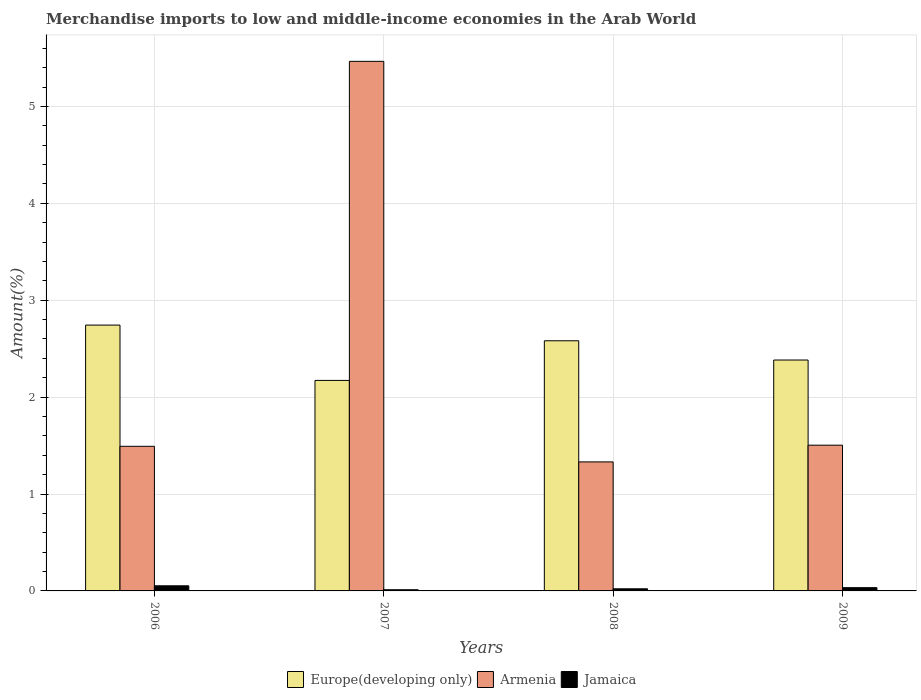How many groups of bars are there?
Keep it short and to the point. 4. Are the number of bars on each tick of the X-axis equal?
Your response must be concise. Yes. In how many cases, is the number of bars for a given year not equal to the number of legend labels?
Make the answer very short. 0. What is the percentage of amount earned from merchandise imports in Armenia in 2007?
Offer a very short reply. 5.47. Across all years, what is the maximum percentage of amount earned from merchandise imports in Armenia?
Make the answer very short. 5.47. Across all years, what is the minimum percentage of amount earned from merchandise imports in Jamaica?
Your answer should be very brief. 0.01. In which year was the percentage of amount earned from merchandise imports in Europe(developing only) maximum?
Your answer should be compact. 2006. In which year was the percentage of amount earned from merchandise imports in Europe(developing only) minimum?
Your answer should be compact. 2007. What is the total percentage of amount earned from merchandise imports in Jamaica in the graph?
Offer a very short reply. 0.12. What is the difference between the percentage of amount earned from merchandise imports in Jamaica in 2007 and that in 2008?
Ensure brevity in your answer.  -0.01. What is the difference between the percentage of amount earned from merchandise imports in Europe(developing only) in 2007 and the percentage of amount earned from merchandise imports in Armenia in 2006?
Make the answer very short. 0.68. What is the average percentage of amount earned from merchandise imports in Europe(developing only) per year?
Provide a succinct answer. 2.47. In the year 2009, what is the difference between the percentage of amount earned from merchandise imports in Europe(developing only) and percentage of amount earned from merchandise imports in Armenia?
Ensure brevity in your answer.  0.88. In how many years, is the percentage of amount earned from merchandise imports in Armenia greater than 2.2 %?
Offer a very short reply. 1. What is the ratio of the percentage of amount earned from merchandise imports in Europe(developing only) in 2007 to that in 2009?
Offer a terse response. 0.91. Is the difference between the percentage of amount earned from merchandise imports in Europe(developing only) in 2007 and 2009 greater than the difference between the percentage of amount earned from merchandise imports in Armenia in 2007 and 2009?
Provide a succinct answer. No. What is the difference between the highest and the second highest percentage of amount earned from merchandise imports in Jamaica?
Give a very brief answer. 0.02. What is the difference between the highest and the lowest percentage of amount earned from merchandise imports in Europe(developing only)?
Your response must be concise. 0.57. In how many years, is the percentage of amount earned from merchandise imports in Jamaica greater than the average percentage of amount earned from merchandise imports in Jamaica taken over all years?
Your response must be concise. 2. Is the sum of the percentage of amount earned from merchandise imports in Europe(developing only) in 2007 and 2008 greater than the maximum percentage of amount earned from merchandise imports in Jamaica across all years?
Ensure brevity in your answer.  Yes. What does the 1st bar from the left in 2008 represents?
Your answer should be very brief. Europe(developing only). What does the 3rd bar from the right in 2009 represents?
Your answer should be compact. Europe(developing only). Is it the case that in every year, the sum of the percentage of amount earned from merchandise imports in Armenia and percentage of amount earned from merchandise imports in Europe(developing only) is greater than the percentage of amount earned from merchandise imports in Jamaica?
Keep it short and to the point. Yes. Are all the bars in the graph horizontal?
Your answer should be compact. No. Does the graph contain any zero values?
Offer a terse response. No. Where does the legend appear in the graph?
Your answer should be very brief. Bottom center. How many legend labels are there?
Your answer should be very brief. 3. How are the legend labels stacked?
Give a very brief answer. Horizontal. What is the title of the graph?
Provide a succinct answer. Merchandise imports to low and middle-income economies in the Arab World. Does "Turkmenistan" appear as one of the legend labels in the graph?
Ensure brevity in your answer.  No. What is the label or title of the X-axis?
Make the answer very short. Years. What is the label or title of the Y-axis?
Give a very brief answer. Amount(%). What is the Amount(%) of Europe(developing only) in 2006?
Ensure brevity in your answer.  2.74. What is the Amount(%) in Armenia in 2006?
Provide a short and direct response. 1.49. What is the Amount(%) of Jamaica in 2006?
Your response must be concise. 0.05. What is the Amount(%) in Europe(developing only) in 2007?
Your answer should be compact. 2.17. What is the Amount(%) in Armenia in 2007?
Offer a terse response. 5.47. What is the Amount(%) in Jamaica in 2007?
Your answer should be very brief. 0.01. What is the Amount(%) in Europe(developing only) in 2008?
Keep it short and to the point. 2.58. What is the Amount(%) in Armenia in 2008?
Provide a succinct answer. 1.33. What is the Amount(%) of Jamaica in 2008?
Provide a short and direct response. 0.02. What is the Amount(%) in Europe(developing only) in 2009?
Provide a short and direct response. 2.38. What is the Amount(%) in Armenia in 2009?
Offer a very short reply. 1.5. What is the Amount(%) of Jamaica in 2009?
Offer a terse response. 0.03. Across all years, what is the maximum Amount(%) of Europe(developing only)?
Provide a short and direct response. 2.74. Across all years, what is the maximum Amount(%) of Armenia?
Ensure brevity in your answer.  5.47. Across all years, what is the maximum Amount(%) in Jamaica?
Give a very brief answer. 0.05. Across all years, what is the minimum Amount(%) in Europe(developing only)?
Your answer should be very brief. 2.17. Across all years, what is the minimum Amount(%) of Armenia?
Offer a very short reply. 1.33. Across all years, what is the minimum Amount(%) of Jamaica?
Ensure brevity in your answer.  0.01. What is the total Amount(%) in Europe(developing only) in the graph?
Your response must be concise. 9.88. What is the total Amount(%) of Armenia in the graph?
Make the answer very short. 9.79. What is the total Amount(%) of Jamaica in the graph?
Keep it short and to the point. 0.12. What is the difference between the Amount(%) of Europe(developing only) in 2006 and that in 2007?
Your response must be concise. 0.57. What is the difference between the Amount(%) of Armenia in 2006 and that in 2007?
Make the answer very short. -3.97. What is the difference between the Amount(%) of Jamaica in 2006 and that in 2007?
Provide a succinct answer. 0.04. What is the difference between the Amount(%) in Europe(developing only) in 2006 and that in 2008?
Keep it short and to the point. 0.16. What is the difference between the Amount(%) of Armenia in 2006 and that in 2008?
Give a very brief answer. 0.16. What is the difference between the Amount(%) in Jamaica in 2006 and that in 2008?
Give a very brief answer. 0.03. What is the difference between the Amount(%) in Europe(developing only) in 2006 and that in 2009?
Ensure brevity in your answer.  0.36. What is the difference between the Amount(%) in Armenia in 2006 and that in 2009?
Your response must be concise. -0.01. What is the difference between the Amount(%) of Jamaica in 2006 and that in 2009?
Offer a terse response. 0.02. What is the difference between the Amount(%) in Europe(developing only) in 2007 and that in 2008?
Your answer should be compact. -0.41. What is the difference between the Amount(%) of Armenia in 2007 and that in 2008?
Provide a succinct answer. 4.13. What is the difference between the Amount(%) in Jamaica in 2007 and that in 2008?
Your response must be concise. -0.01. What is the difference between the Amount(%) in Europe(developing only) in 2007 and that in 2009?
Provide a short and direct response. -0.21. What is the difference between the Amount(%) in Armenia in 2007 and that in 2009?
Offer a very short reply. 3.96. What is the difference between the Amount(%) of Jamaica in 2007 and that in 2009?
Offer a terse response. -0.02. What is the difference between the Amount(%) of Europe(developing only) in 2008 and that in 2009?
Provide a short and direct response. 0.2. What is the difference between the Amount(%) in Armenia in 2008 and that in 2009?
Provide a short and direct response. -0.17. What is the difference between the Amount(%) of Jamaica in 2008 and that in 2009?
Ensure brevity in your answer.  -0.01. What is the difference between the Amount(%) in Europe(developing only) in 2006 and the Amount(%) in Armenia in 2007?
Ensure brevity in your answer.  -2.72. What is the difference between the Amount(%) of Europe(developing only) in 2006 and the Amount(%) of Jamaica in 2007?
Provide a succinct answer. 2.73. What is the difference between the Amount(%) in Armenia in 2006 and the Amount(%) in Jamaica in 2007?
Provide a succinct answer. 1.48. What is the difference between the Amount(%) in Europe(developing only) in 2006 and the Amount(%) in Armenia in 2008?
Give a very brief answer. 1.41. What is the difference between the Amount(%) in Europe(developing only) in 2006 and the Amount(%) in Jamaica in 2008?
Offer a terse response. 2.72. What is the difference between the Amount(%) of Armenia in 2006 and the Amount(%) of Jamaica in 2008?
Your answer should be compact. 1.47. What is the difference between the Amount(%) of Europe(developing only) in 2006 and the Amount(%) of Armenia in 2009?
Your response must be concise. 1.24. What is the difference between the Amount(%) in Europe(developing only) in 2006 and the Amount(%) in Jamaica in 2009?
Offer a terse response. 2.71. What is the difference between the Amount(%) in Armenia in 2006 and the Amount(%) in Jamaica in 2009?
Give a very brief answer. 1.46. What is the difference between the Amount(%) of Europe(developing only) in 2007 and the Amount(%) of Armenia in 2008?
Keep it short and to the point. 0.84. What is the difference between the Amount(%) of Europe(developing only) in 2007 and the Amount(%) of Jamaica in 2008?
Your response must be concise. 2.15. What is the difference between the Amount(%) in Armenia in 2007 and the Amount(%) in Jamaica in 2008?
Give a very brief answer. 5.44. What is the difference between the Amount(%) in Europe(developing only) in 2007 and the Amount(%) in Armenia in 2009?
Make the answer very short. 0.67. What is the difference between the Amount(%) in Europe(developing only) in 2007 and the Amount(%) in Jamaica in 2009?
Make the answer very short. 2.14. What is the difference between the Amount(%) in Armenia in 2007 and the Amount(%) in Jamaica in 2009?
Your answer should be very brief. 5.43. What is the difference between the Amount(%) of Europe(developing only) in 2008 and the Amount(%) of Armenia in 2009?
Offer a very short reply. 1.08. What is the difference between the Amount(%) in Europe(developing only) in 2008 and the Amount(%) in Jamaica in 2009?
Your answer should be compact. 2.55. What is the difference between the Amount(%) in Armenia in 2008 and the Amount(%) in Jamaica in 2009?
Your response must be concise. 1.3. What is the average Amount(%) of Europe(developing only) per year?
Your answer should be compact. 2.47. What is the average Amount(%) in Armenia per year?
Ensure brevity in your answer.  2.45. What is the average Amount(%) in Jamaica per year?
Your answer should be very brief. 0.03. In the year 2006, what is the difference between the Amount(%) of Europe(developing only) and Amount(%) of Armenia?
Keep it short and to the point. 1.25. In the year 2006, what is the difference between the Amount(%) of Europe(developing only) and Amount(%) of Jamaica?
Provide a succinct answer. 2.69. In the year 2006, what is the difference between the Amount(%) in Armenia and Amount(%) in Jamaica?
Provide a succinct answer. 1.44. In the year 2007, what is the difference between the Amount(%) in Europe(developing only) and Amount(%) in Armenia?
Keep it short and to the point. -3.29. In the year 2007, what is the difference between the Amount(%) of Europe(developing only) and Amount(%) of Jamaica?
Offer a very short reply. 2.16. In the year 2007, what is the difference between the Amount(%) of Armenia and Amount(%) of Jamaica?
Provide a succinct answer. 5.45. In the year 2008, what is the difference between the Amount(%) of Europe(developing only) and Amount(%) of Armenia?
Your response must be concise. 1.25. In the year 2008, what is the difference between the Amount(%) in Europe(developing only) and Amount(%) in Jamaica?
Your answer should be compact. 2.56. In the year 2008, what is the difference between the Amount(%) of Armenia and Amount(%) of Jamaica?
Provide a succinct answer. 1.31. In the year 2009, what is the difference between the Amount(%) of Europe(developing only) and Amount(%) of Armenia?
Keep it short and to the point. 0.88. In the year 2009, what is the difference between the Amount(%) of Europe(developing only) and Amount(%) of Jamaica?
Offer a very short reply. 2.35. In the year 2009, what is the difference between the Amount(%) in Armenia and Amount(%) in Jamaica?
Provide a succinct answer. 1.47. What is the ratio of the Amount(%) in Europe(developing only) in 2006 to that in 2007?
Keep it short and to the point. 1.26. What is the ratio of the Amount(%) of Armenia in 2006 to that in 2007?
Offer a very short reply. 0.27. What is the ratio of the Amount(%) in Jamaica in 2006 to that in 2007?
Provide a short and direct response. 4.35. What is the ratio of the Amount(%) in Europe(developing only) in 2006 to that in 2008?
Provide a short and direct response. 1.06. What is the ratio of the Amount(%) in Armenia in 2006 to that in 2008?
Offer a terse response. 1.12. What is the ratio of the Amount(%) in Jamaica in 2006 to that in 2008?
Provide a succinct answer. 2.42. What is the ratio of the Amount(%) of Europe(developing only) in 2006 to that in 2009?
Provide a short and direct response. 1.15. What is the ratio of the Amount(%) of Armenia in 2006 to that in 2009?
Give a very brief answer. 0.99. What is the ratio of the Amount(%) in Jamaica in 2006 to that in 2009?
Your response must be concise. 1.57. What is the ratio of the Amount(%) in Europe(developing only) in 2007 to that in 2008?
Provide a succinct answer. 0.84. What is the ratio of the Amount(%) of Armenia in 2007 to that in 2008?
Ensure brevity in your answer.  4.1. What is the ratio of the Amount(%) in Jamaica in 2007 to that in 2008?
Give a very brief answer. 0.56. What is the ratio of the Amount(%) of Europe(developing only) in 2007 to that in 2009?
Provide a succinct answer. 0.91. What is the ratio of the Amount(%) of Armenia in 2007 to that in 2009?
Give a very brief answer. 3.63. What is the ratio of the Amount(%) in Jamaica in 2007 to that in 2009?
Make the answer very short. 0.36. What is the ratio of the Amount(%) of Europe(developing only) in 2008 to that in 2009?
Provide a succinct answer. 1.08. What is the ratio of the Amount(%) of Armenia in 2008 to that in 2009?
Ensure brevity in your answer.  0.89. What is the ratio of the Amount(%) in Jamaica in 2008 to that in 2009?
Offer a terse response. 0.65. What is the difference between the highest and the second highest Amount(%) in Europe(developing only)?
Provide a short and direct response. 0.16. What is the difference between the highest and the second highest Amount(%) of Armenia?
Your response must be concise. 3.96. What is the difference between the highest and the second highest Amount(%) of Jamaica?
Offer a terse response. 0.02. What is the difference between the highest and the lowest Amount(%) in Europe(developing only)?
Provide a succinct answer. 0.57. What is the difference between the highest and the lowest Amount(%) in Armenia?
Give a very brief answer. 4.13. What is the difference between the highest and the lowest Amount(%) of Jamaica?
Your answer should be very brief. 0.04. 